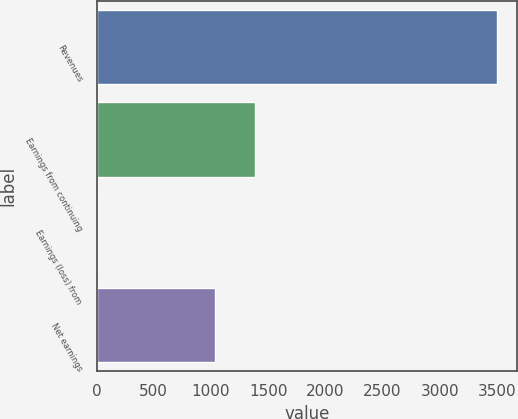Convert chart to OTSL. <chart><loc_0><loc_0><loc_500><loc_500><bar_chart><fcel>Revenues<fcel>Earnings from continuing<fcel>Earnings (loss) from<fcel>Net earnings<nl><fcel>3502<fcel>1388<fcel>2<fcel>1038<nl></chart> 